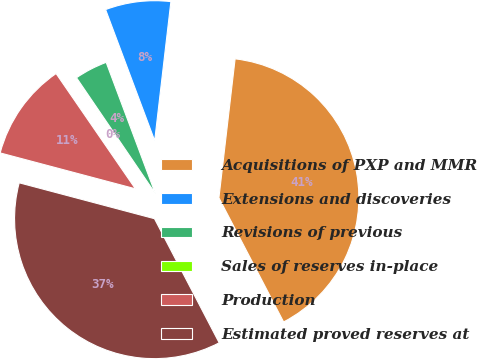<chart> <loc_0><loc_0><loc_500><loc_500><pie_chart><fcel>Acquisitions of PXP and MMR<fcel>Extensions and discoveries<fcel>Revisions of previous<fcel>Sales of reserves in-place<fcel>Production<fcel>Estimated proved reserves at<nl><fcel>40.51%<fcel>7.55%<fcel>3.81%<fcel>0.08%<fcel>11.28%<fcel>36.78%<nl></chart> 